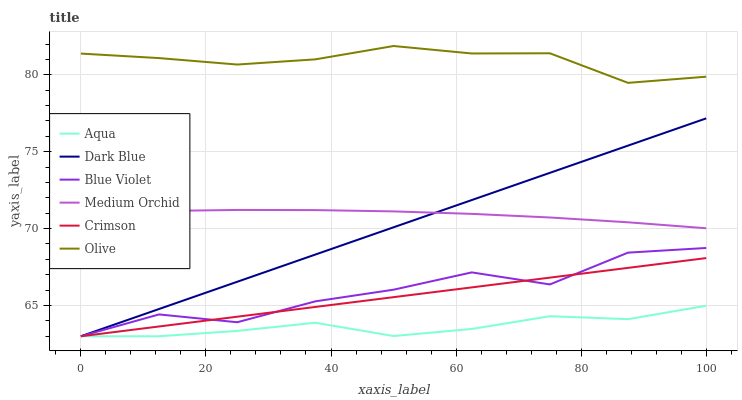Does Aqua have the minimum area under the curve?
Answer yes or no. Yes. Does Olive have the maximum area under the curve?
Answer yes or no. Yes. Does Medium Orchid have the minimum area under the curve?
Answer yes or no. No. Does Medium Orchid have the maximum area under the curve?
Answer yes or no. No. Is Crimson the smoothest?
Answer yes or no. Yes. Is Blue Violet the roughest?
Answer yes or no. Yes. Is Medium Orchid the smoothest?
Answer yes or no. No. Is Medium Orchid the roughest?
Answer yes or no. No. Does Aqua have the lowest value?
Answer yes or no. Yes. Does Medium Orchid have the lowest value?
Answer yes or no. No. Does Olive have the highest value?
Answer yes or no. Yes. Does Medium Orchid have the highest value?
Answer yes or no. No. Is Blue Violet less than Medium Orchid?
Answer yes or no. Yes. Is Medium Orchid greater than Aqua?
Answer yes or no. Yes. Does Blue Violet intersect Dark Blue?
Answer yes or no. Yes. Is Blue Violet less than Dark Blue?
Answer yes or no. No. Is Blue Violet greater than Dark Blue?
Answer yes or no. No. Does Blue Violet intersect Medium Orchid?
Answer yes or no. No. 